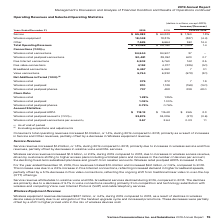According to Verizon Communications's financial document, How much did Consumer’s total operating revenues increase in 2019? According to the financial document, $1.3 billion. The relevant text states: "Consumer’s total operating revenues increased $1.3 billion, or 1.4%, during 2019 compared to 2018, primarily as a result of increases in Service and Other rev..." Also, Why did Consumer’s total operating revenues increase in 2019? as a result of increases in Service and Other revenues, partially offset by a decrease in Wireless equipment revenue.. The document states: ", or 1.4%, during 2019 compared to 2018, primarily as a result of increases in Service and Other revenues, partially offset by a decrease in Wireless ..." Also, How much did Service Revenue increase in 2019? According to the financial document, $1.2 billion. The relevant text states: "Service revenue increased $1.2 billion, or 1.8%, during 2019 compared to 2018, primarily due to increases in wireless service and Fios rev..." Also, can you calculate: What is the change in Service revenue from 2018 to 2019? Based on the calculation: 65,383-64,223, the result is 1160 (in millions). This is based on the information: "Service $ 65,383 $ 64,223 $ 1,160 1.8% Service $ 65,383 $ 64,223 $ 1,160 1.8%..." The key data points involved are: 64,223, 65,383. Also, can you calculate: What is the change in Wireless equipment revenue from 2018 to 2019? Based on the calculation: 18,048-18,875, the result is -827 (in millions). This is based on the information: "Wireless equipment 18,048 18,875 (827) (4.4) Wireless equipment 18,048 18,875 (827) (4.4)..." The key data points involved are: 18,048, 18,875. Also, can you calculate: What is the change in Total Operating Revenues from 2018 to 2019? Based on the calculation: 91,056-89,762, the result is 1294 (in millions). This is based on the information: "Total Operating Revenues $ 91,056 $ 89,762 $ 1,294 1.4 Total Operating Revenues $ 91,056 $ 89,762 $ 1,294 1.4..." The key data points involved are: 89,762, 91,056. 